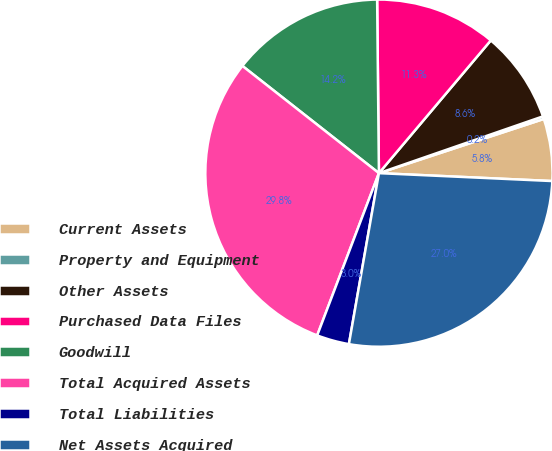Convert chart. <chart><loc_0><loc_0><loc_500><loc_500><pie_chart><fcel>Current Assets<fcel>Property and Equipment<fcel>Other Assets<fcel>Purchased Data Files<fcel>Goodwill<fcel>Total Acquired Assets<fcel>Total Liabilities<fcel>Net Assets Acquired<nl><fcel>5.78%<fcel>0.25%<fcel>8.55%<fcel>11.31%<fcel>14.24%<fcel>29.81%<fcel>3.02%<fcel>27.04%<nl></chart> 